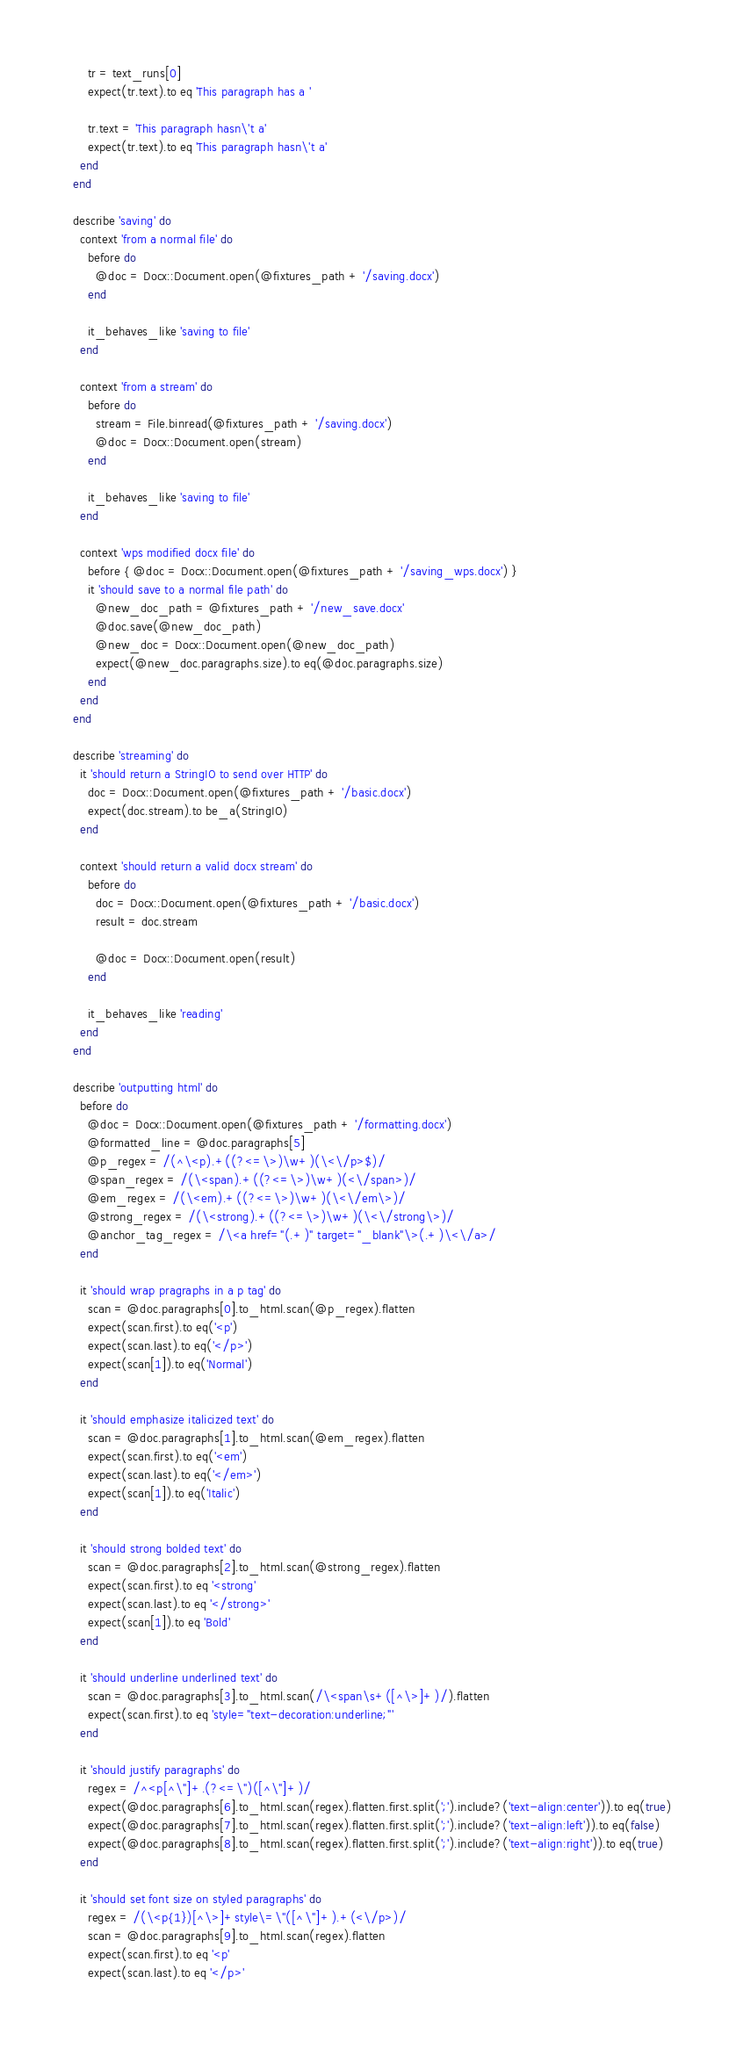<code> <loc_0><loc_0><loc_500><loc_500><_Ruby_>
      tr = text_runs[0]
      expect(tr.text).to eq 'This paragraph has a '

      tr.text = 'This paragraph hasn\'t a'
      expect(tr.text).to eq 'This paragraph hasn\'t a'
    end
  end

  describe 'saving' do
    context 'from a normal file' do
      before do
        @doc = Docx::Document.open(@fixtures_path + '/saving.docx')
      end

      it_behaves_like 'saving to file'
    end

    context 'from a stream' do
      before do
        stream = File.binread(@fixtures_path + '/saving.docx')
        @doc = Docx::Document.open(stream)
      end

      it_behaves_like 'saving to file'
    end

    context 'wps modified docx file' do
      before { @doc = Docx::Document.open(@fixtures_path + '/saving_wps.docx') }
      it 'should save to a normal file path' do
        @new_doc_path = @fixtures_path + '/new_save.docx'
        @doc.save(@new_doc_path)
        @new_doc = Docx::Document.open(@new_doc_path)
        expect(@new_doc.paragraphs.size).to eq(@doc.paragraphs.size)
      end
    end
  end

  describe 'streaming' do
    it 'should return a StringIO to send over HTTP' do
      doc = Docx::Document.open(@fixtures_path + '/basic.docx')
      expect(doc.stream).to be_a(StringIO)
    end

    context 'should return a valid docx stream' do
      before do
        doc = Docx::Document.open(@fixtures_path + '/basic.docx')
        result = doc.stream

        @doc = Docx::Document.open(result)
      end

      it_behaves_like 'reading'
    end
  end

  describe 'outputting html' do
    before do
      @doc = Docx::Document.open(@fixtures_path + '/formatting.docx')
      @formatted_line = @doc.paragraphs[5]
      @p_regex = /(^\<p).+((?<=\>)\w+)(\<\/p>$)/
      @span_regex = /(\<span).+((?<=\>)\w+)(<\/span>)/
      @em_regex = /(\<em).+((?<=\>)\w+)(\<\/em\>)/
      @strong_regex = /(\<strong).+((?<=\>)\w+)(\<\/strong\>)/
      @anchor_tag_regex = /\<a href="(.+)" target="_blank"\>(.+)\<\/a>/
    end

    it 'should wrap pragraphs in a p tag' do
      scan = @doc.paragraphs[0].to_html.scan(@p_regex).flatten
      expect(scan.first).to eq('<p')
      expect(scan.last).to eq('</p>')
      expect(scan[1]).to eq('Normal')
    end

    it 'should emphasize italicized text' do
      scan = @doc.paragraphs[1].to_html.scan(@em_regex).flatten
      expect(scan.first).to eq('<em')
      expect(scan.last).to eq('</em>')
      expect(scan[1]).to eq('Italic')
    end

    it 'should strong bolded text' do
      scan = @doc.paragraphs[2].to_html.scan(@strong_regex).flatten
      expect(scan.first).to eq '<strong'
      expect(scan.last).to eq '</strong>'
      expect(scan[1]).to eq 'Bold'
    end

    it 'should underline underlined text' do
      scan = @doc.paragraphs[3].to_html.scan(/\<span\s+([^\>]+)/).flatten
      expect(scan.first).to eq 'style="text-decoration:underline;"'
    end

    it 'should justify paragraphs' do
      regex = /^<p[^\"]+.(?<=\")([^\"]+)/
      expect(@doc.paragraphs[6].to_html.scan(regex).flatten.first.split(';').include?('text-align:center')).to eq(true)
      expect(@doc.paragraphs[7].to_html.scan(regex).flatten.first.split(';').include?('text-align:left')).to eq(false)
      expect(@doc.paragraphs[8].to_html.scan(regex).flatten.first.split(';').include?('text-align:right')).to eq(true)
    end

    it 'should set font size on styled paragraphs' do
      regex = /(\<p{1})[^\>]+style\=\"([^\"]+).+(<\/p>)/
      scan = @doc.paragraphs[9].to_html.scan(regex).flatten
      expect(scan.first).to eq '<p'
      expect(scan.last).to eq '</p>'</code> 